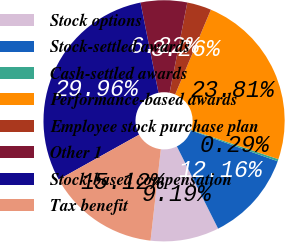Convert chart to OTSL. <chart><loc_0><loc_0><loc_500><loc_500><pie_chart><fcel>Stock options<fcel>Stock-settled awards<fcel>Cash-settled awards<fcel>Performance-based awards<fcel>Employee stock purchase plan<fcel>Other 1<fcel>Stock-based compensation<fcel>Tax benefit<nl><fcel>9.19%<fcel>12.16%<fcel>0.29%<fcel>23.81%<fcel>3.26%<fcel>6.22%<fcel>29.96%<fcel>15.12%<nl></chart> 